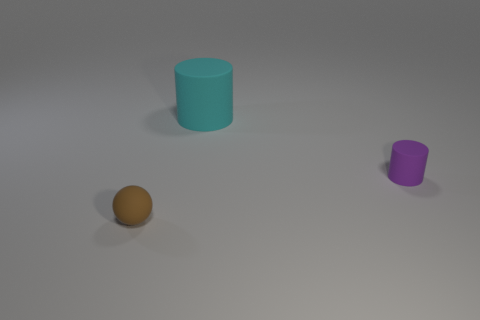Subtract all blue spheres. Subtract all gray cylinders. How many spheres are left? 1 Subtract all brown balls. How many purple cylinders are left? 1 Subtract 1 cyan cylinders. How many objects are left? 2 Subtract all cylinders. How many objects are left? 1 Subtract 1 cylinders. How many cylinders are left? 1 Subtract all tiny brown rubber spheres. Subtract all brown balls. How many objects are left? 1 Add 3 tiny purple matte cylinders. How many tiny purple matte cylinders are left? 4 Add 1 small green metallic cylinders. How many small green metallic cylinders exist? 1 Add 1 purple objects. How many objects exist? 4 